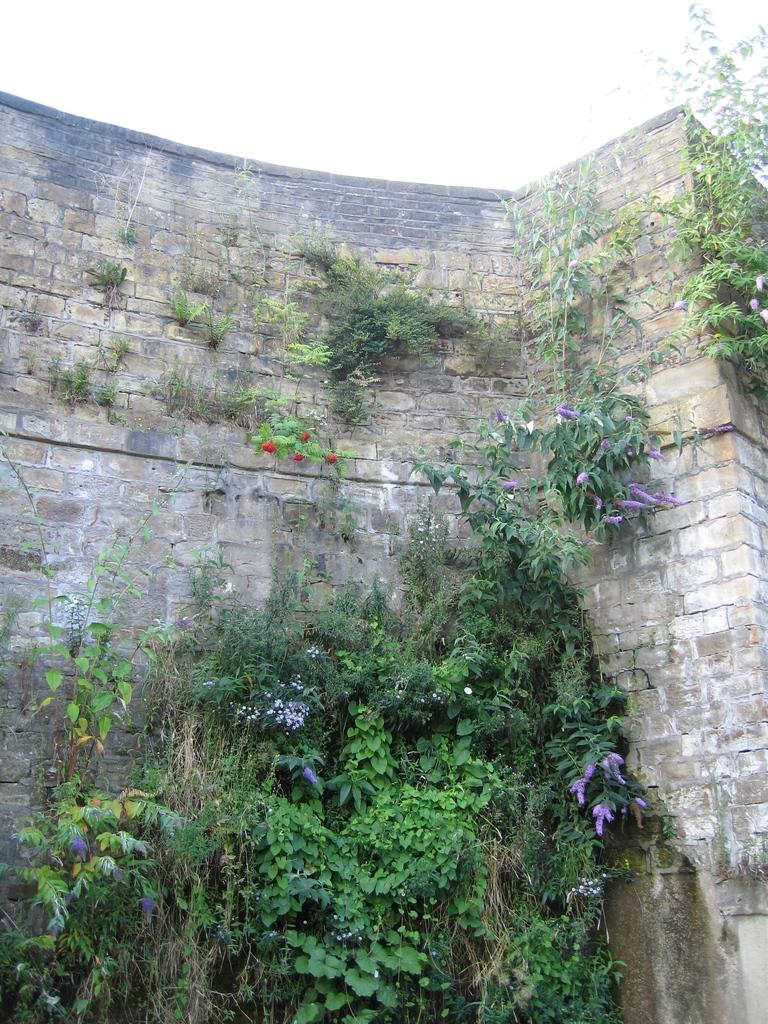What type of structure is present in the image? There is a wall in the image. What natural elements can be seen in the image? There are trees, plants, and flowers in the image. What is visible at the top of the image? The sky is visible at the top of the image. How many boats are visible in the image? There are no boats present in the image. What type of yarn is being used to create the flowers in the image? There is no yarn present in the image, as the flowers are real flowers and not made of yarn. 